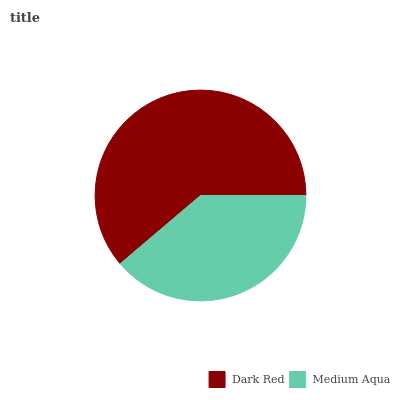Is Medium Aqua the minimum?
Answer yes or no. Yes. Is Dark Red the maximum?
Answer yes or no. Yes. Is Medium Aqua the maximum?
Answer yes or no. No. Is Dark Red greater than Medium Aqua?
Answer yes or no. Yes. Is Medium Aqua less than Dark Red?
Answer yes or no. Yes. Is Medium Aqua greater than Dark Red?
Answer yes or no. No. Is Dark Red less than Medium Aqua?
Answer yes or no. No. Is Dark Red the high median?
Answer yes or no. Yes. Is Medium Aqua the low median?
Answer yes or no. Yes. Is Medium Aqua the high median?
Answer yes or no. No. Is Dark Red the low median?
Answer yes or no. No. 